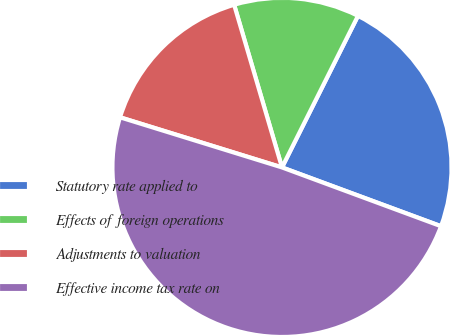<chart> <loc_0><loc_0><loc_500><loc_500><pie_chart><fcel>Statutory rate applied to<fcel>Effects of foreign operations<fcel>Adjustments to valuation<fcel>Effective income tax rate on<nl><fcel>23.24%<fcel>11.95%<fcel>15.67%<fcel>49.14%<nl></chart> 